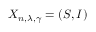Convert formula to latex. <formula><loc_0><loc_0><loc_500><loc_500>X _ { n , \lambda , \gamma } = \left ( S , I \right )</formula> 